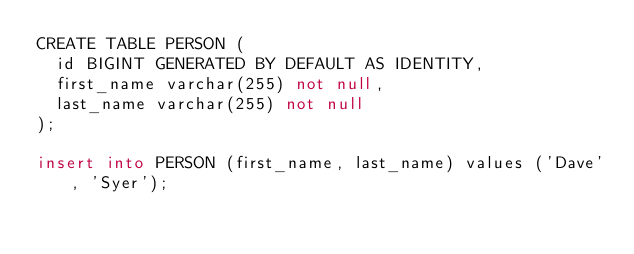Convert code to text. <code><loc_0><loc_0><loc_500><loc_500><_SQL_>CREATE TABLE PERSON (
	id BIGINT GENERATED BY DEFAULT AS IDENTITY,
	first_name varchar(255) not null,
	last_name varchar(255) not null
);

insert into PERSON (first_name, last_name) values ('Dave', 'Syer');
</code> 